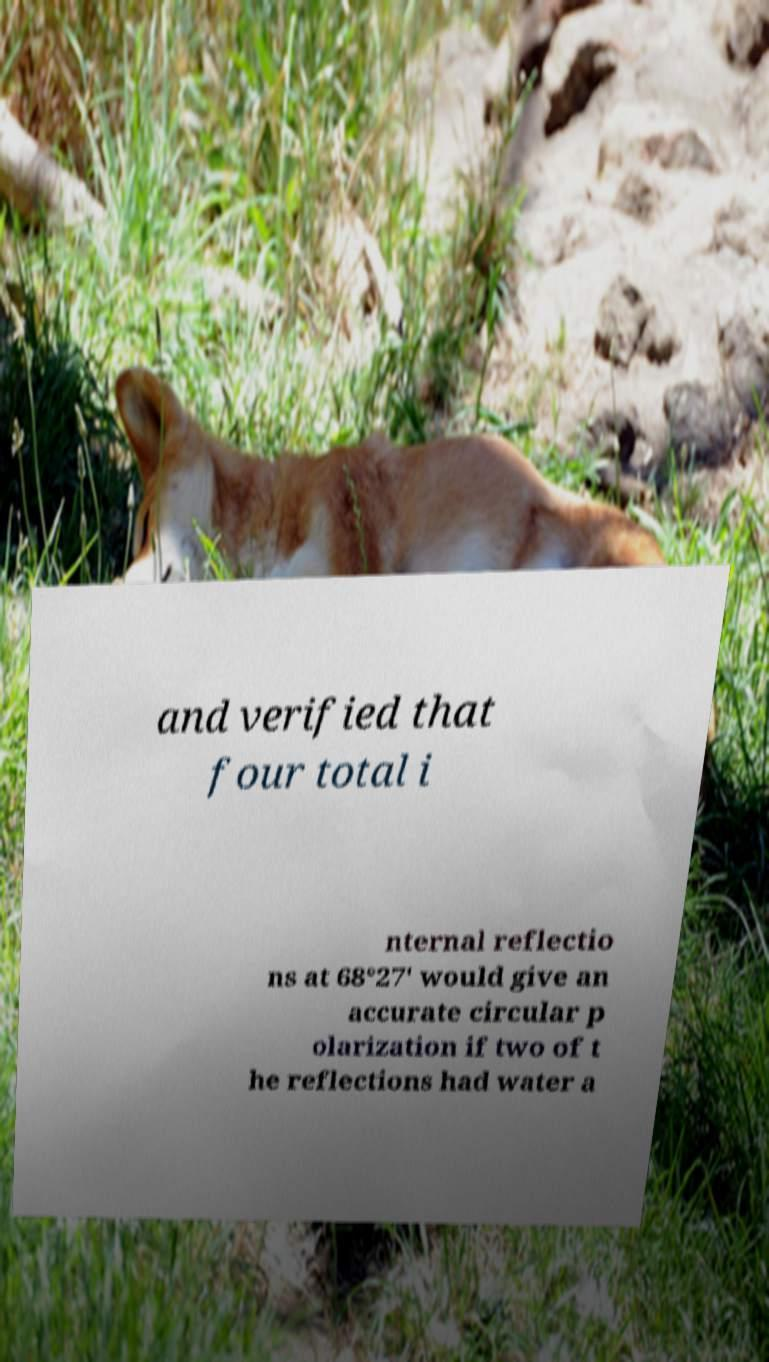What messages or text are displayed in this image? I need them in a readable, typed format. and verified that four total i nternal reflectio ns at 68°27' would give an accurate circular p olarization if two of t he reflections had water a 